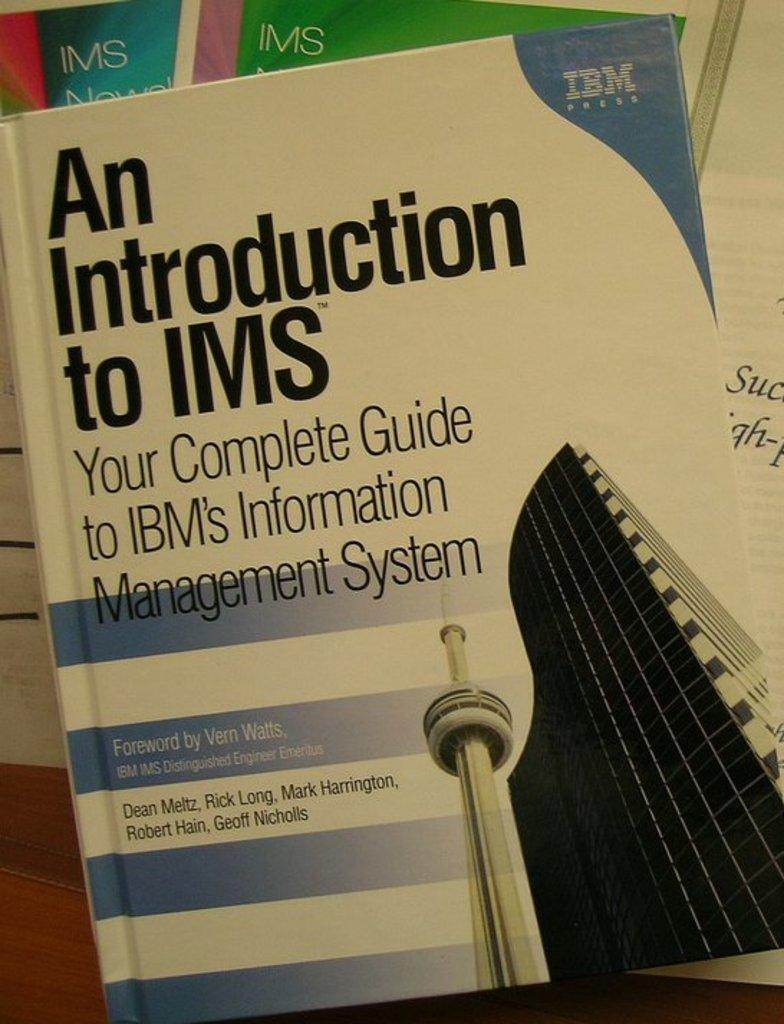<image>
Offer a succinct explanation of the picture presented. A white and blue book about a guide to IBM's Information Management System. 